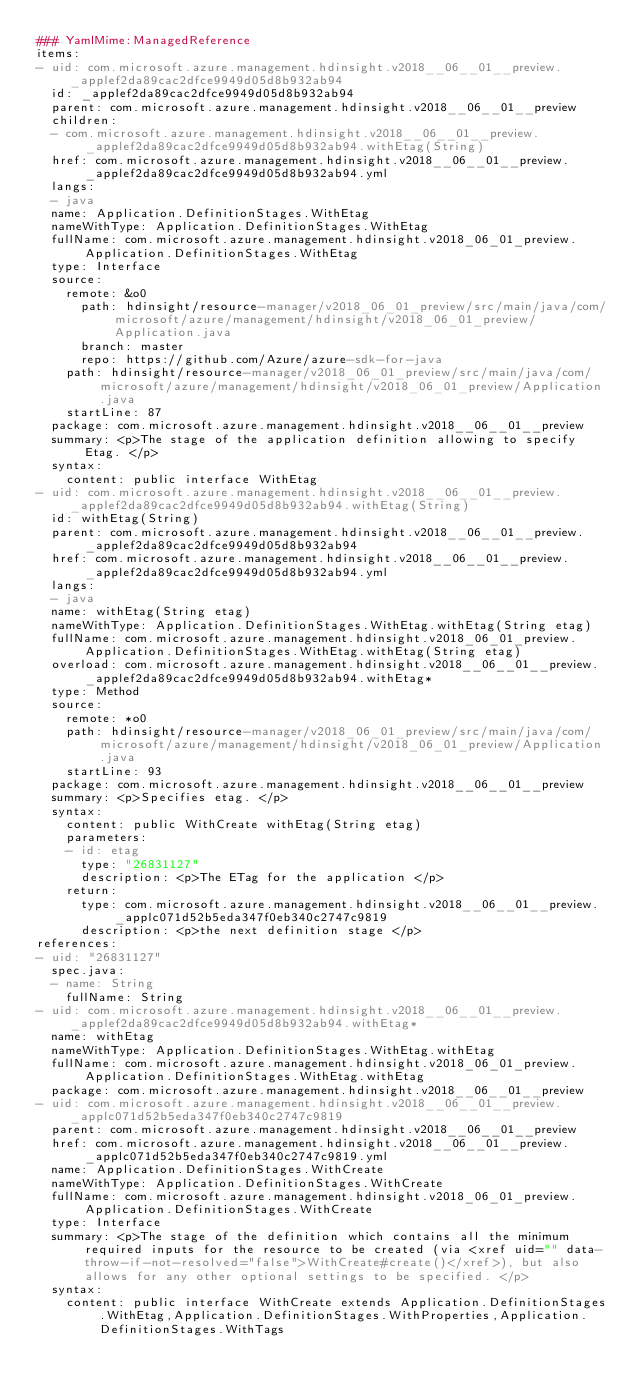Convert code to text. <code><loc_0><loc_0><loc_500><loc_500><_YAML_>### YamlMime:ManagedReference
items:
- uid: com.microsoft.azure.management.hdinsight.v2018__06__01__preview._applef2da89cac2dfce9949d05d8b932ab94
  id: _applef2da89cac2dfce9949d05d8b932ab94
  parent: com.microsoft.azure.management.hdinsight.v2018__06__01__preview
  children:
  - com.microsoft.azure.management.hdinsight.v2018__06__01__preview._applef2da89cac2dfce9949d05d8b932ab94.withEtag(String)
  href: com.microsoft.azure.management.hdinsight.v2018__06__01__preview._applef2da89cac2dfce9949d05d8b932ab94.yml
  langs:
  - java
  name: Application.DefinitionStages.WithEtag
  nameWithType: Application.DefinitionStages.WithEtag
  fullName: com.microsoft.azure.management.hdinsight.v2018_06_01_preview.Application.DefinitionStages.WithEtag
  type: Interface
  source:
    remote: &o0
      path: hdinsight/resource-manager/v2018_06_01_preview/src/main/java/com/microsoft/azure/management/hdinsight/v2018_06_01_preview/Application.java
      branch: master
      repo: https://github.com/Azure/azure-sdk-for-java
    path: hdinsight/resource-manager/v2018_06_01_preview/src/main/java/com/microsoft/azure/management/hdinsight/v2018_06_01_preview/Application.java
    startLine: 87
  package: com.microsoft.azure.management.hdinsight.v2018__06__01__preview
  summary: <p>The stage of the application definition allowing to specify Etag. </p>
  syntax:
    content: public interface WithEtag
- uid: com.microsoft.azure.management.hdinsight.v2018__06__01__preview._applef2da89cac2dfce9949d05d8b932ab94.withEtag(String)
  id: withEtag(String)
  parent: com.microsoft.azure.management.hdinsight.v2018__06__01__preview._applef2da89cac2dfce9949d05d8b932ab94
  href: com.microsoft.azure.management.hdinsight.v2018__06__01__preview._applef2da89cac2dfce9949d05d8b932ab94.yml
  langs:
  - java
  name: withEtag(String etag)
  nameWithType: Application.DefinitionStages.WithEtag.withEtag(String etag)
  fullName: com.microsoft.azure.management.hdinsight.v2018_06_01_preview.Application.DefinitionStages.WithEtag.withEtag(String etag)
  overload: com.microsoft.azure.management.hdinsight.v2018__06__01__preview._applef2da89cac2dfce9949d05d8b932ab94.withEtag*
  type: Method
  source:
    remote: *o0
    path: hdinsight/resource-manager/v2018_06_01_preview/src/main/java/com/microsoft/azure/management/hdinsight/v2018_06_01_preview/Application.java
    startLine: 93
  package: com.microsoft.azure.management.hdinsight.v2018__06__01__preview
  summary: <p>Specifies etag. </p>
  syntax:
    content: public WithCreate withEtag(String etag)
    parameters:
    - id: etag
      type: "26831127"
      description: <p>The ETag for the application </p>
    return:
      type: com.microsoft.azure.management.hdinsight.v2018__06__01__preview._applc071d52b5eda347f0eb340c2747c9819
      description: <p>the next definition stage </p>
references:
- uid: "26831127"
  spec.java:
  - name: String
    fullName: String
- uid: com.microsoft.azure.management.hdinsight.v2018__06__01__preview._applef2da89cac2dfce9949d05d8b932ab94.withEtag*
  name: withEtag
  nameWithType: Application.DefinitionStages.WithEtag.withEtag
  fullName: com.microsoft.azure.management.hdinsight.v2018_06_01_preview.Application.DefinitionStages.WithEtag.withEtag
  package: com.microsoft.azure.management.hdinsight.v2018__06__01__preview
- uid: com.microsoft.azure.management.hdinsight.v2018__06__01__preview._applc071d52b5eda347f0eb340c2747c9819
  parent: com.microsoft.azure.management.hdinsight.v2018__06__01__preview
  href: com.microsoft.azure.management.hdinsight.v2018__06__01__preview._applc071d52b5eda347f0eb340c2747c9819.yml
  name: Application.DefinitionStages.WithCreate
  nameWithType: Application.DefinitionStages.WithCreate
  fullName: com.microsoft.azure.management.hdinsight.v2018_06_01_preview.Application.DefinitionStages.WithCreate
  type: Interface
  summary: <p>The stage of the definition which contains all the minimum required inputs for the resource to be created (via <xref uid="" data-throw-if-not-resolved="false">WithCreate#create()</xref>), but also allows for any other optional settings to be specified. </p>
  syntax:
    content: public interface WithCreate extends Application.DefinitionStages.WithEtag,Application.DefinitionStages.WithProperties,Application.DefinitionStages.WithTags
</code> 